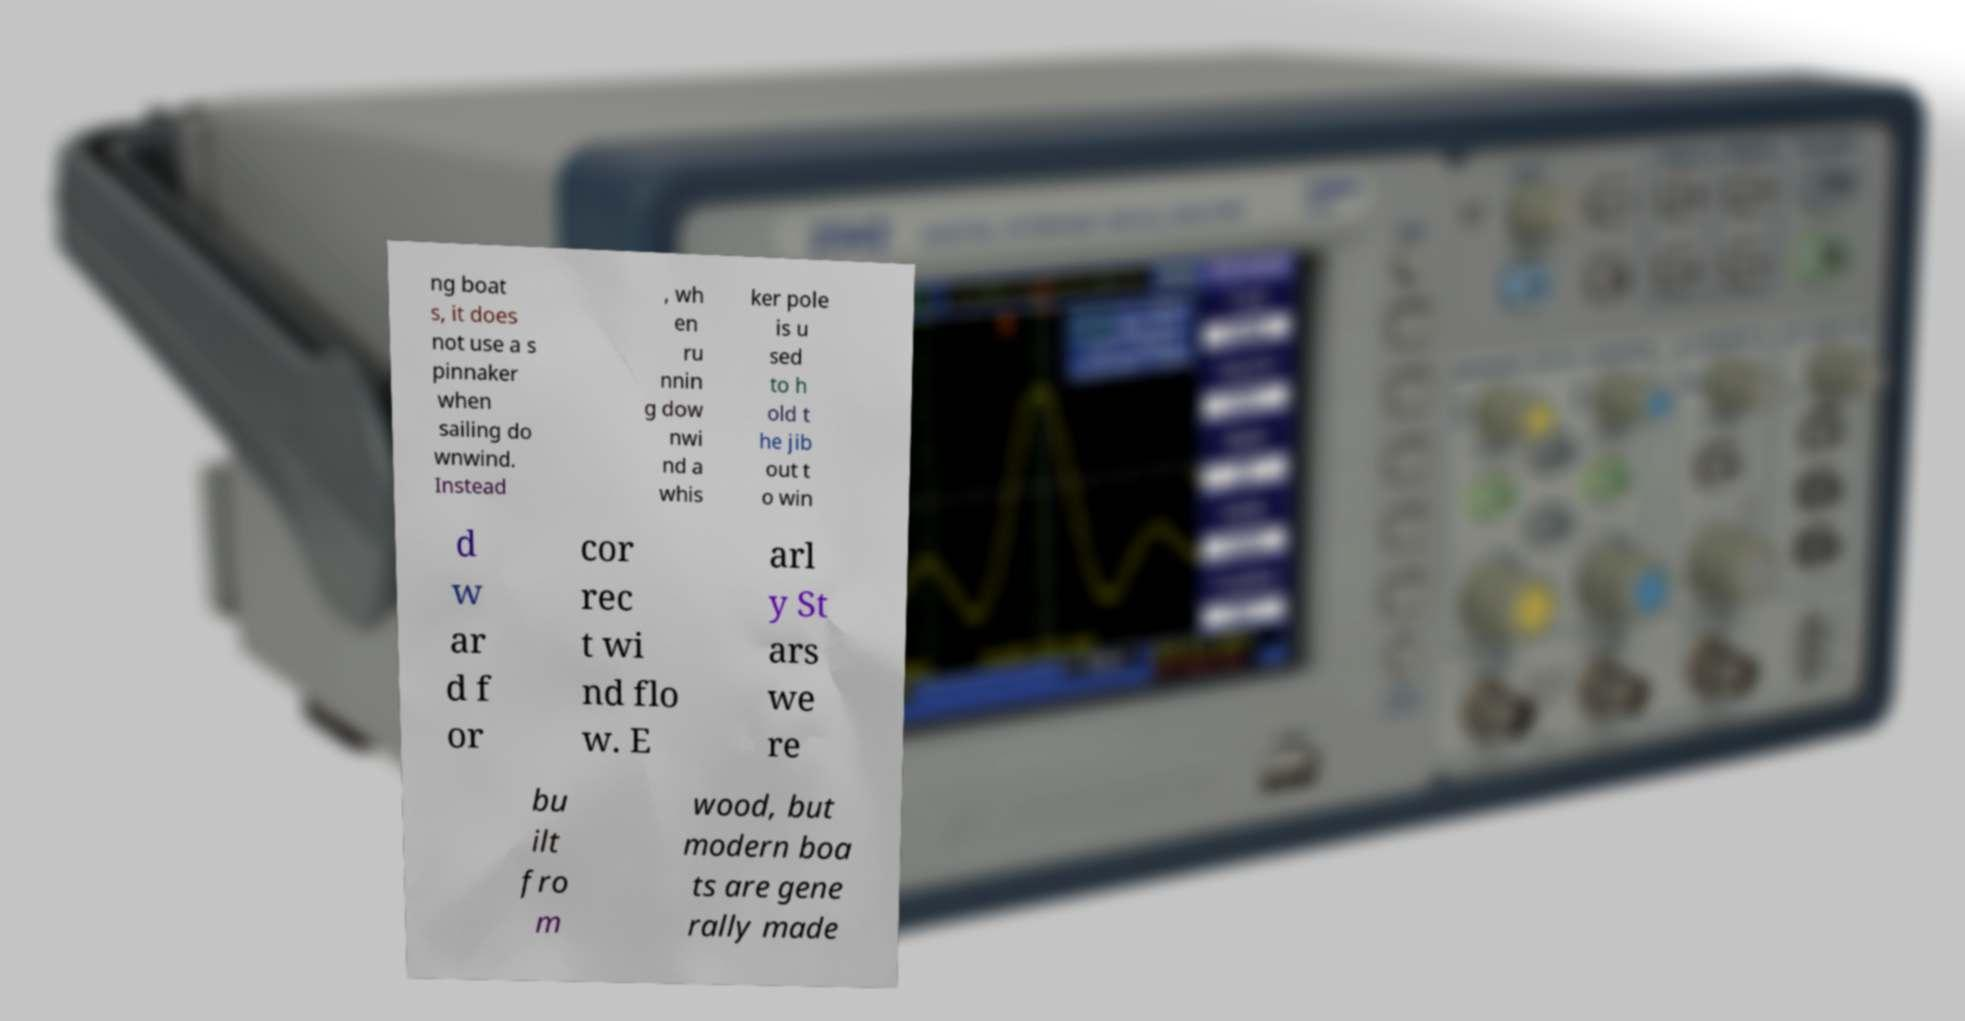I need the written content from this picture converted into text. Can you do that? ng boat s, it does not use a s pinnaker when sailing do wnwind. Instead , wh en ru nnin g dow nwi nd a whis ker pole is u sed to h old t he jib out t o win d w ar d f or cor rec t wi nd flo w. E arl y St ars we re bu ilt fro m wood, but modern boa ts are gene rally made 